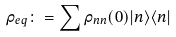<formula> <loc_0><loc_0><loc_500><loc_500>\rho _ { e q } \colon = \sum \rho _ { n n } ( 0 ) | n \rangle \langle n |</formula> 